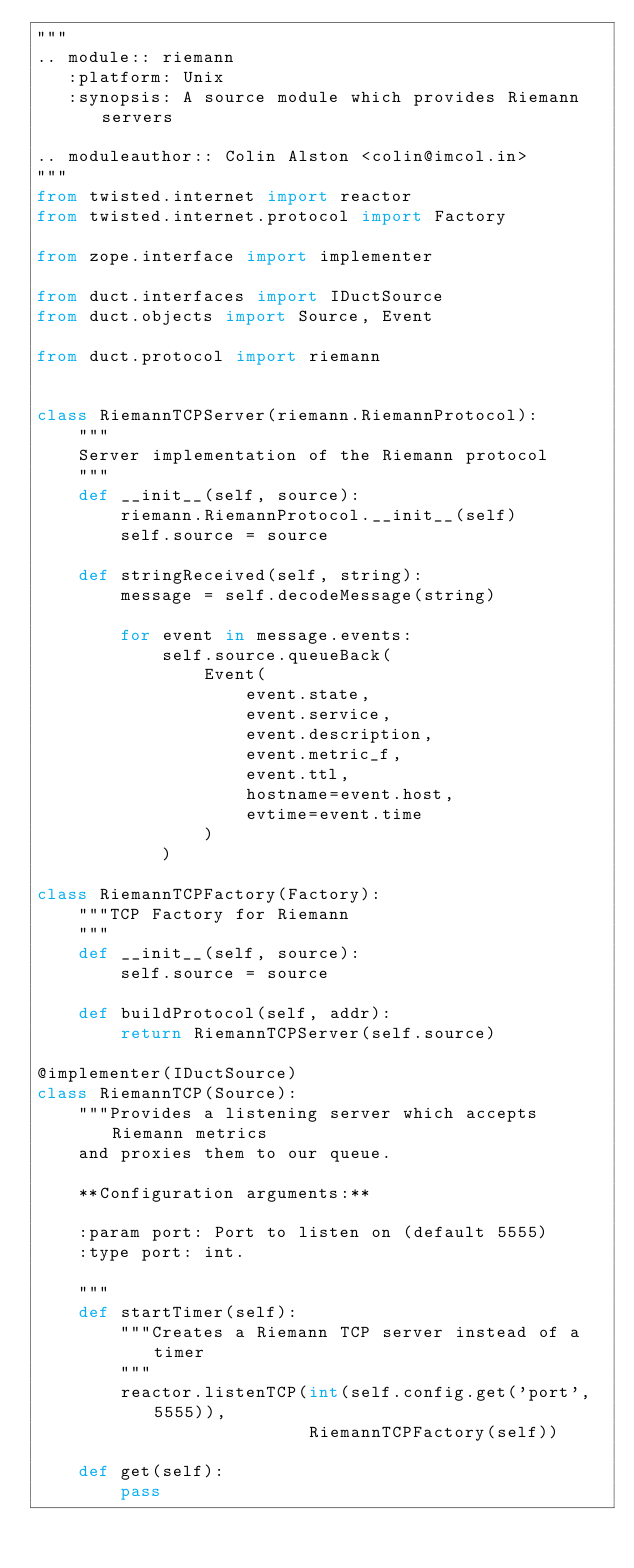<code> <loc_0><loc_0><loc_500><loc_500><_Python_>"""
.. module:: riemann
   :platform: Unix
   :synopsis: A source module which provides Riemann servers

.. moduleauthor:: Colin Alston <colin@imcol.in>
"""
from twisted.internet import reactor
from twisted.internet.protocol import Factory

from zope.interface import implementer

from duct.interfaces import IDuctSource
from duct.objects import Source, Event

from duct.protocol import riemann


class RiemannTCPServer(riemann.RiemannProtocol):
    """
    Server implementation of the Riemann protocol
    """
    def __init__(self, source):
        riemann.RiemannProtocol.__init__(self)
        self.source = source

    def stringReceived(self, string):
        message = self.decodeMessage(string)

        for event in message.events:
            self.source.queueBack(
                Event(
                    event.state,
                    event.service,
                    event.description,
                    event.metric_f,
                    event.ttl,
                    hostname=event.host,
                    evtime=event.time
                )
            )

class RiemannTCPFactory(Factory):
    """TCP Factory for Riemann
    """
    def __init__(self, source):
        self.source = source

    def buildProtocol(self, addr):
        return RiemannTCPServer(self.source)

@implementer(IDuctSource)
class RiemannTCP(Source):
    """Provides a listening server which accepts Riemann metrics
    and proxies them to our queue.

    **Configuration arguments:**

    :param port: Port to listen on (default 5555)
    :type port: int.

    """
    def startTimer(self):
        """Creates a Riemann TCP server instead of a timer
        """
        reactor.listenTCP(int(self.config.get('port', 5555)),
                          RiemannTCPFactory(self))

    def get(self):
        pass
</code> 